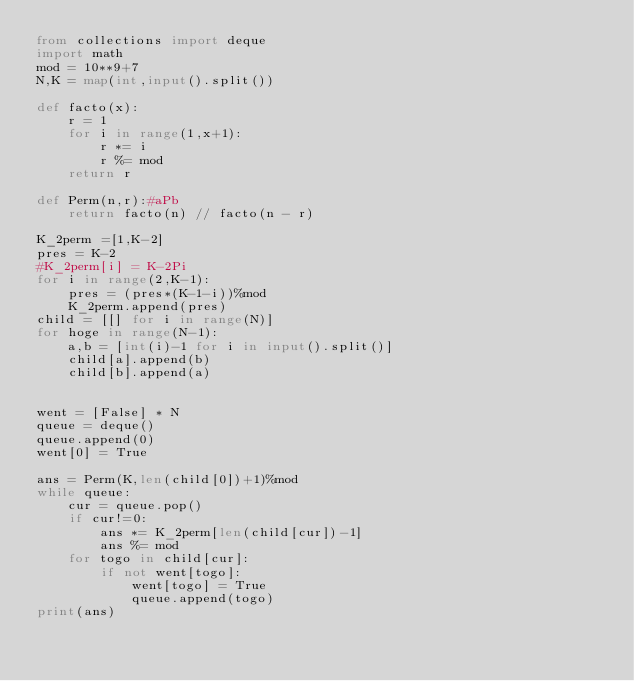<code> <loc_0><loc_0><loc_500><loc_500><_Python_>from collections import deque
import math
mod = 10**9+7
N,K = map(int,input().split())

def facto(x):
    r = 1
    for i in range(1,x+1):
        r *= i
        r %= mod
    return r

def Perm(n,r):#aPb
    return facto(n) // facto(n - r)

K_2perm =[1,K-2]
pres = K-2
#K_2perm[i] = K-2Pi
for i in range(2,K-1):
    pres = (pres*(K-1-i))%mod
    K_2perm.append(pres)
child = [[] for i in range(N)]
for hoge in range(N-1):
    a,b = [int(i)-1 for i in input().split()]
    child[a].append(b)
    child[b].append(a)


went = [False] * N
queue = deque()
queue.append(0)
went[0] = True

ans = Perm(K,len(child[0])+1)%mod
while queue:
    cur = queue.pop()
    if cur!=0:
        ans *= K_2perm[len(child[cur])-1]
        ans %= mod
    for togo in child[cur]:
        if not went[togo]:
            went[togo] = True
            queue.append(togo)
print(ans)

</code> 